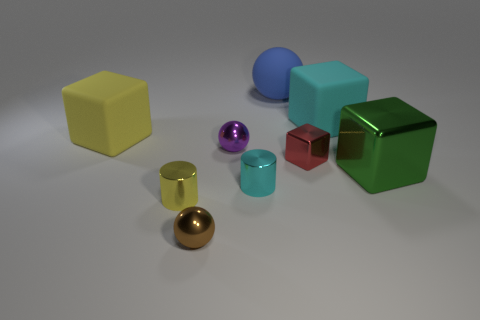There is a large block that is to the left of the ball behind the large block that is to the left of the cyan cube; what is its material?
Your response must be concise. Rubber. Is there any other thing that is made of the same material as the brown sphere?
Your answer should be compact. Yes. There is a matte ball; does it have the same size as the sphere that is in front of the big metallic object?
Provide a succinct answer. No. How many things are tiny spheres that are behind the red cube or metallic spheres to the right of the small brown shiny sphere?
Ensure brevity in your answer.  1. There is a large cube in front of the yellow matte block; what color is it?
Your answer should be very brief. Green. Are there any yellow cylinders to the left of the tiny cylinder that is right of the purple object?
Provide a short and direct response. Yes. Are there fewer green matte balls than cyan matte objects?
Make the answer very short. Yes. What is the material of the ball behind the cyan thing behind the purple sphere?
Ensure brevity in your answer.  Rubber. Is the red cube the same size as the blue ball?
Your answer should be very brief. No. How many objects are shiny spheres or rubber blocks?
Make the answer very short. 4. 